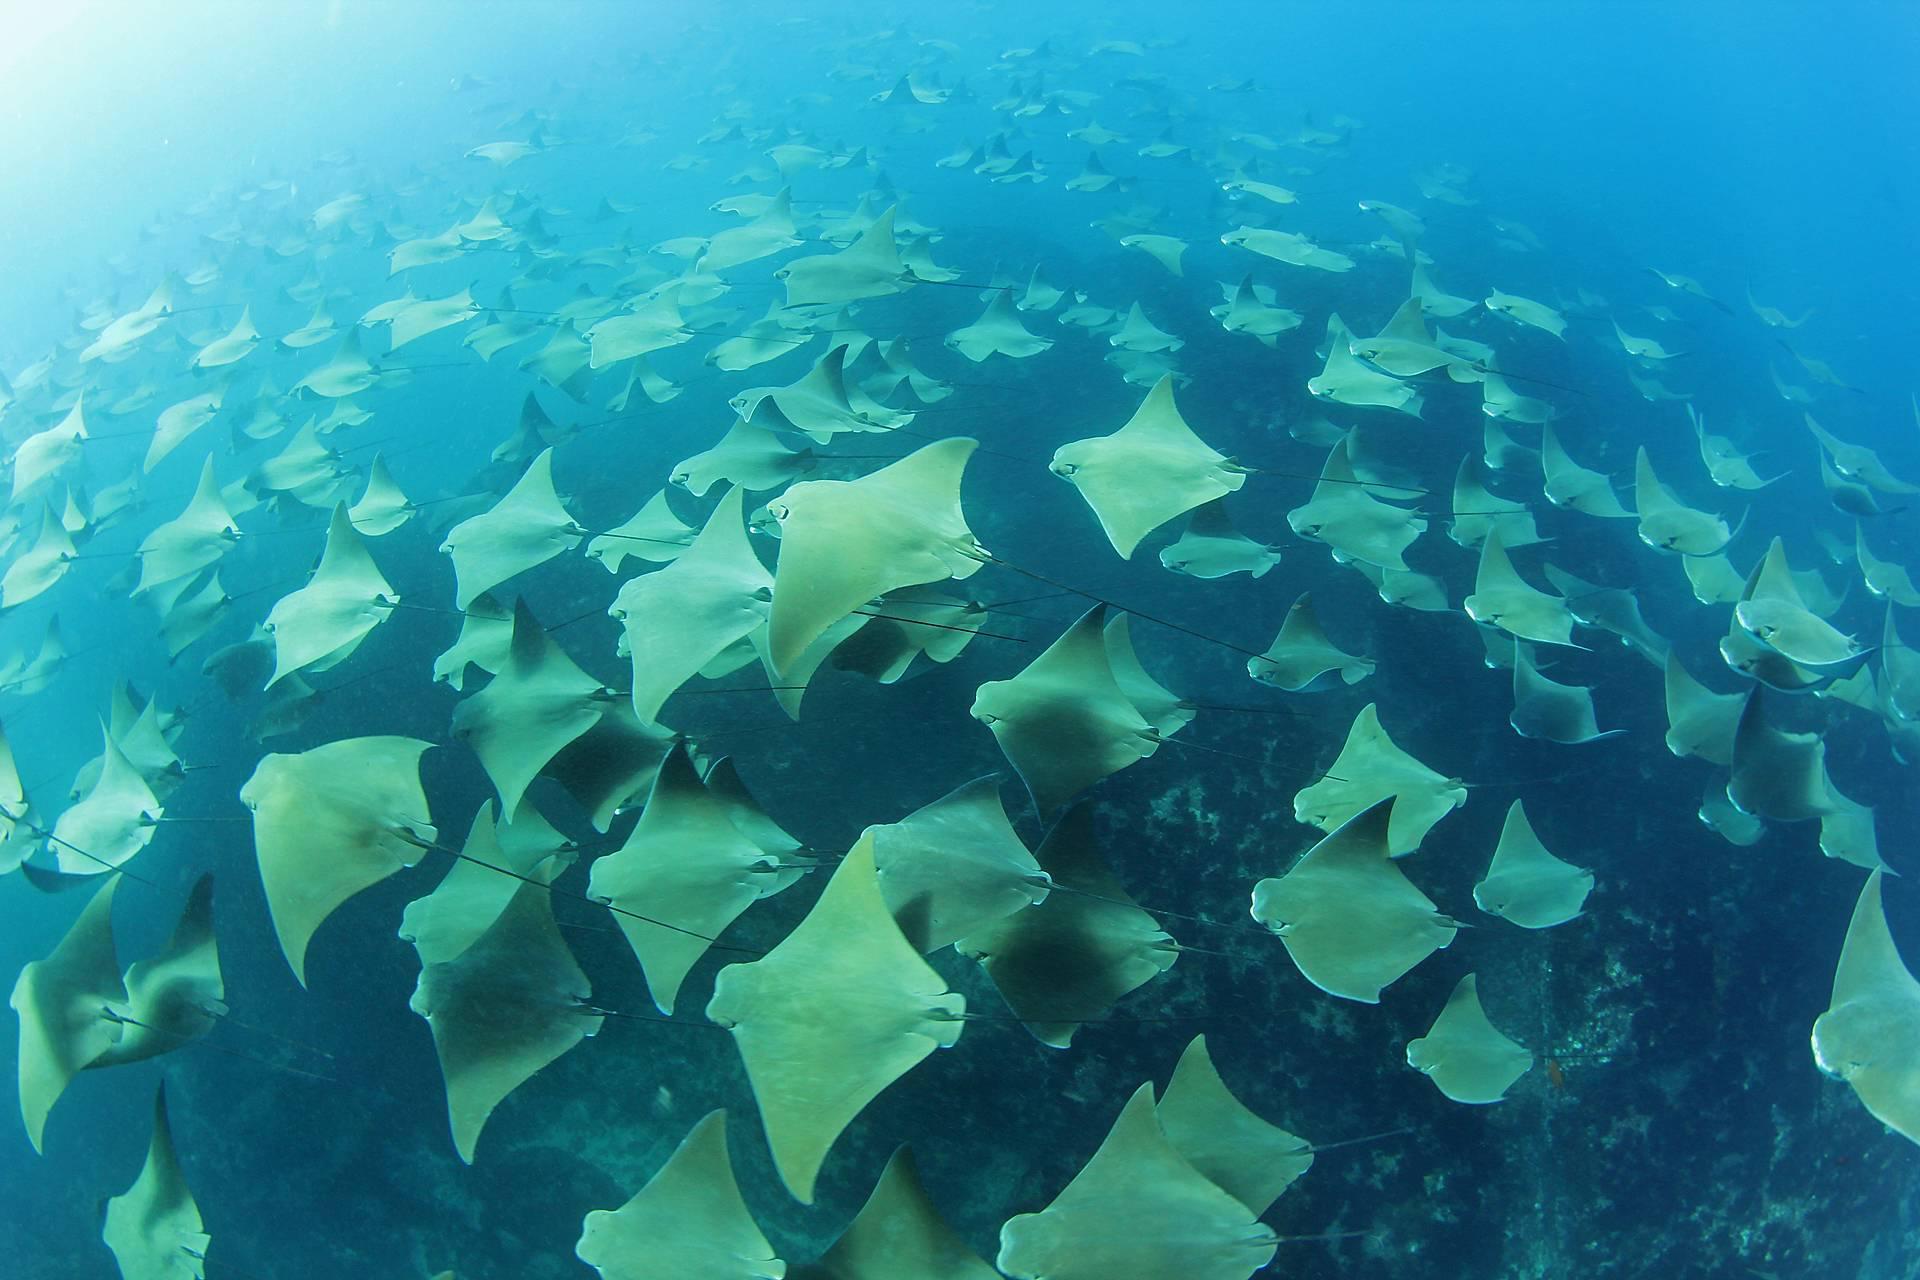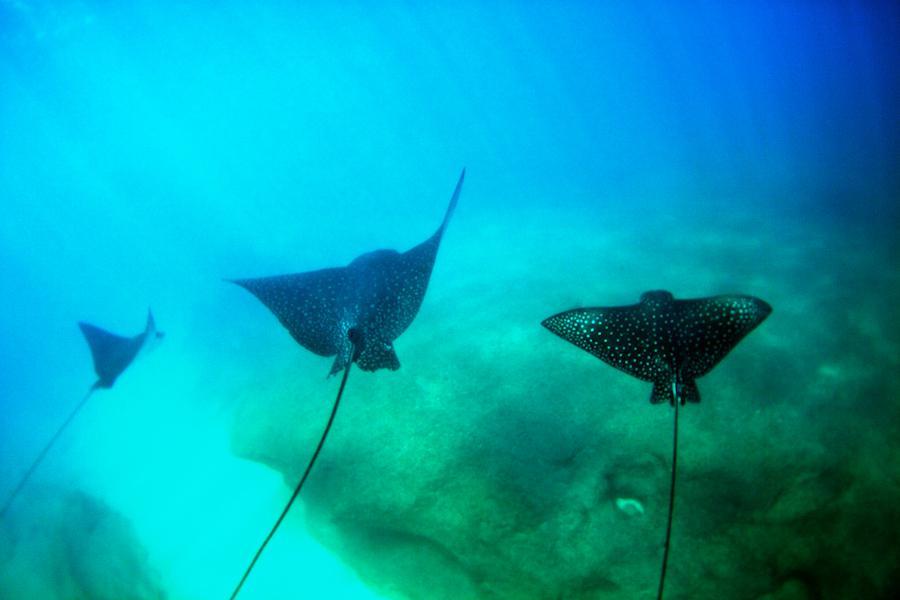The first image is the image on the left, the second image is the image on the right. Analyze the images presented: Is the assertion "There are at most three stingrays." valid? Answer yes or no. No. 